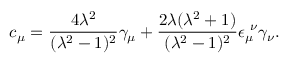Convert formula to latex. <formula><loc_0><loc_0><loc_500><loc_500>c _ { \mu } = \frac { 4 \lambda ^ { 2 } } { ( \lambda ^ { 2 } - 1 ) ^ { 2 } } \gamma _ { \mu } + \frac { 2 \lambda ( \lambda ^ { 2 } + 1 ) } { ( \lambda ^ { 2 } - 1 ) ^ { 2 } } \epsilon _ { \mu } ^ { \nu } \gamma _ { \nu } .</formula> 